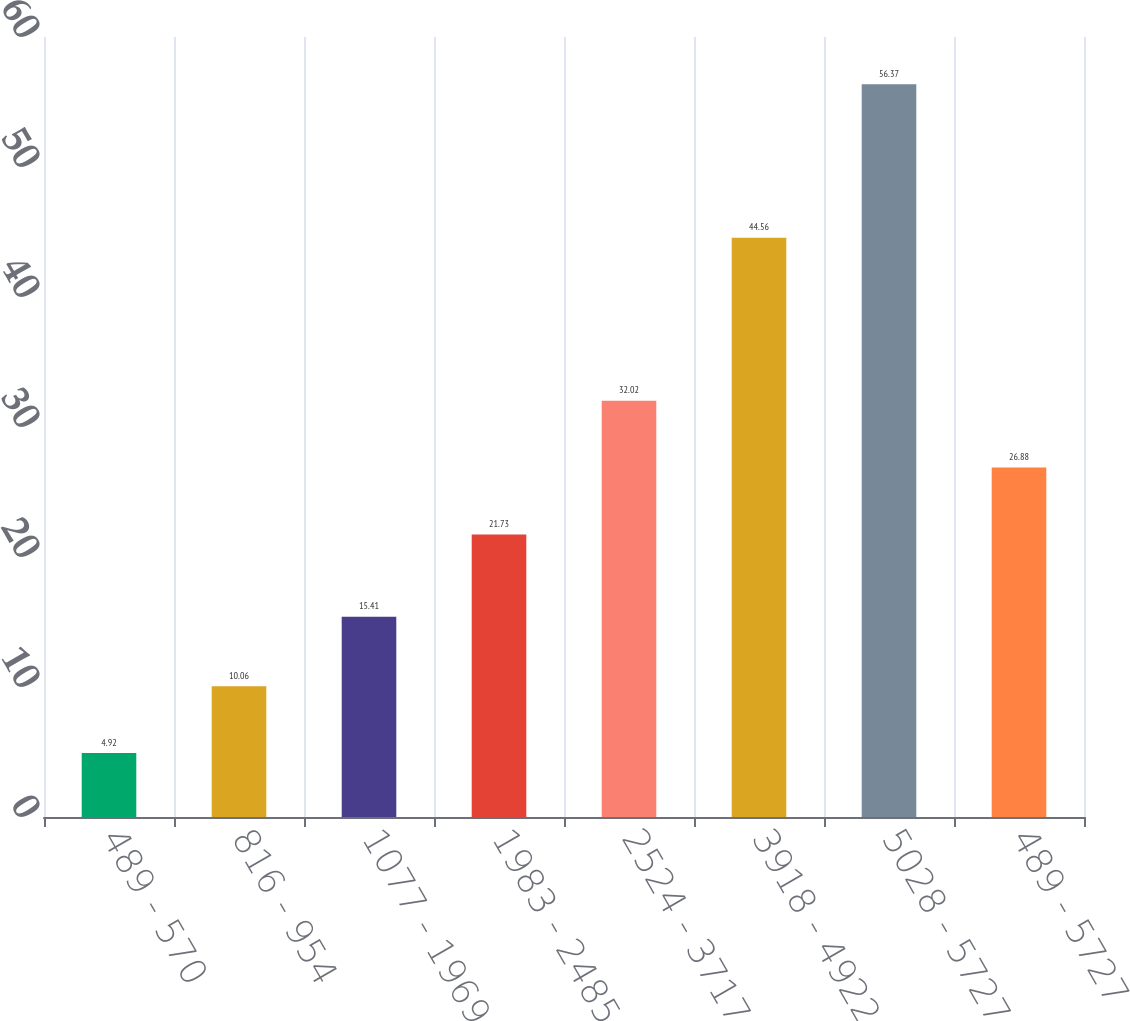<chart> <loc_0><loc_0><loc_500><loc_500><bar_chart><fcel>489 - 570<fcel>816 - 954<fcel>1077 - 1969<fcel>1983 - 2485<fcel>2524 - 3717<fcel>3918 - 4922<fcel>5028 - 5727<fcel>489 - 5727<nl><fcel>4.92<fcel>10.06<fcel>15.41<fcel>21.73<fcel>32.02<fcel>44.56<fcel>56.37<fcel>26.88<nl></chart> 